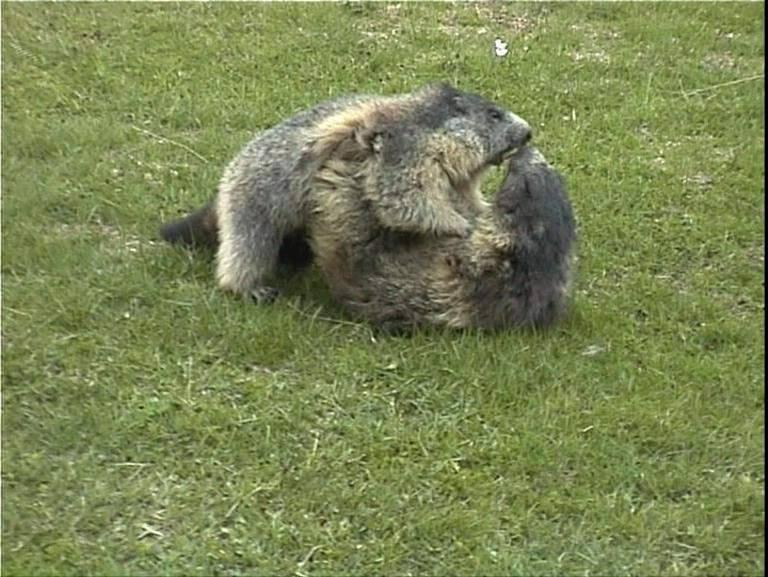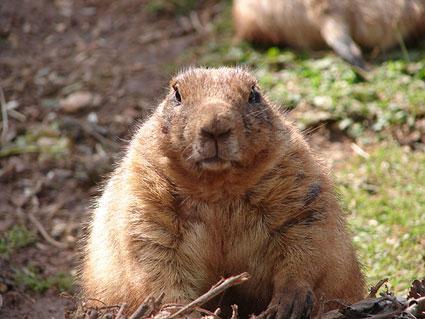The first image is the image on the left, the second image is the image on the right. Evaluate the accuracy of this statement regarding the images: "The left image contains 3 marmots, and the right image contains 2 marmots.". Is it true? Answer yes or no. No. 